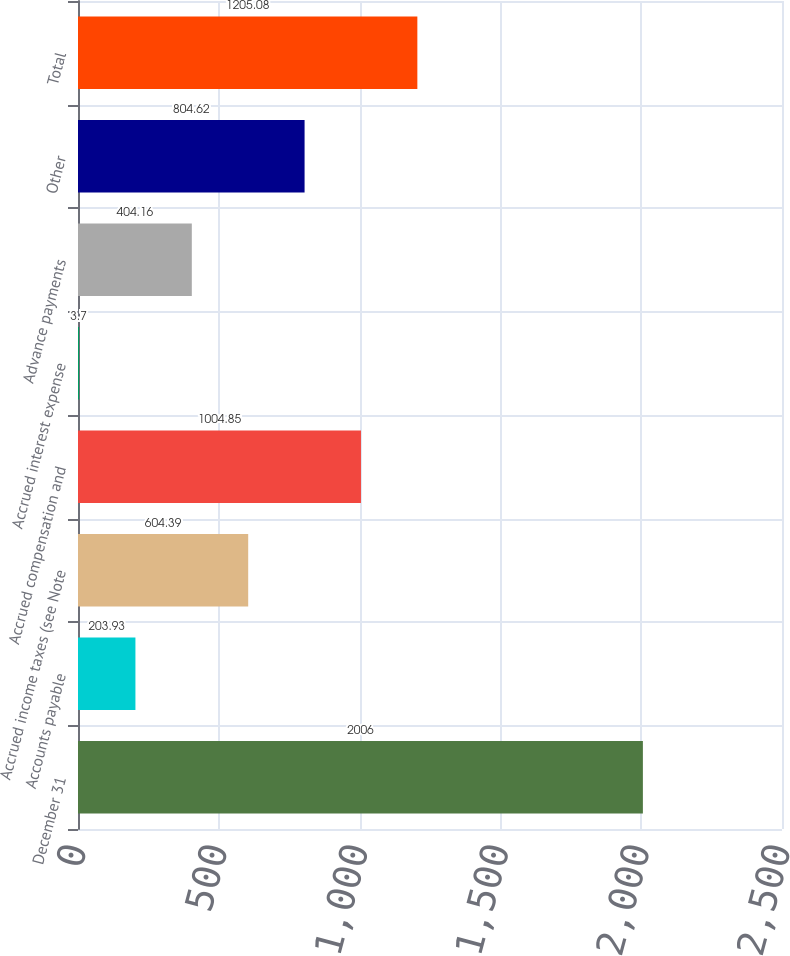<chart> <loc_0><loc_0><loc_500><loc_500><bar_chart><fcel>December 31<fcel>Accounts payable<fcel>Accrued income taxes (see Note<fcel>Accrued compensation and<fcel>Accrued interest expense<fcel>Advance payments<fcel>Other<fcel>Total<nl><fcel>2006<fcel>203.93<fcel>604.39<fcel>1004.85<fcel>3.7<fcel>404.16<fcel>804.62<fcel>1205.08<nl></chart> 